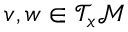<formula> <loc_0><loc_0><loc_500><loc_500>v , w \in \mathcal { T } _ { x } \mathcal { M }</formula> 